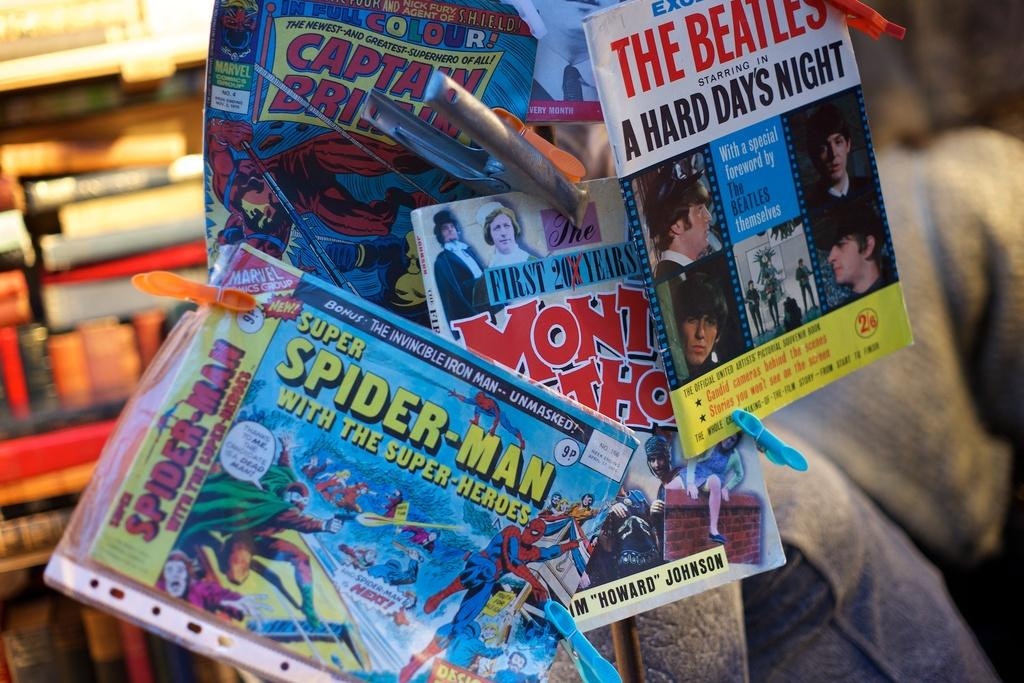<image>
Present a compact description of the photo's key features. magazines with one of them that says 'the beatles' on it 